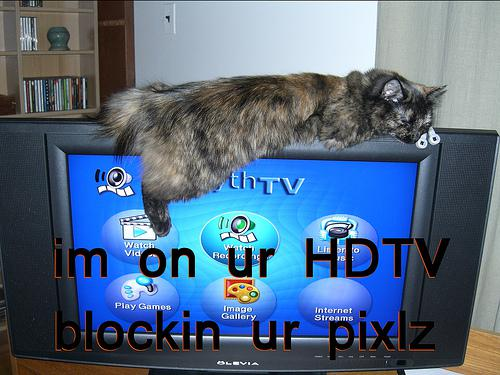Question: what animal is shown?
Choices:
A. Cat.
B. Dog.
C. Chicken.
D. Rabbit.
Answer with the letter. Answer: A Question: how many circular icons are on the tv?
Choices:
A. Five.
B. Three.
C. Six.
D. Zero.
Answer with the letter. Answer: C Question: who made this tv?
Choices:
A. Samsung.
B. Olevia.
C. Panasonic.
D. Sony.
Answer with the letter. Answer: B Question: how many of the cat's ears are visible?
Choices:
A. None.
B. One.
C. There are no cats.
D. Two.
Answer with the letter. Answer: D 